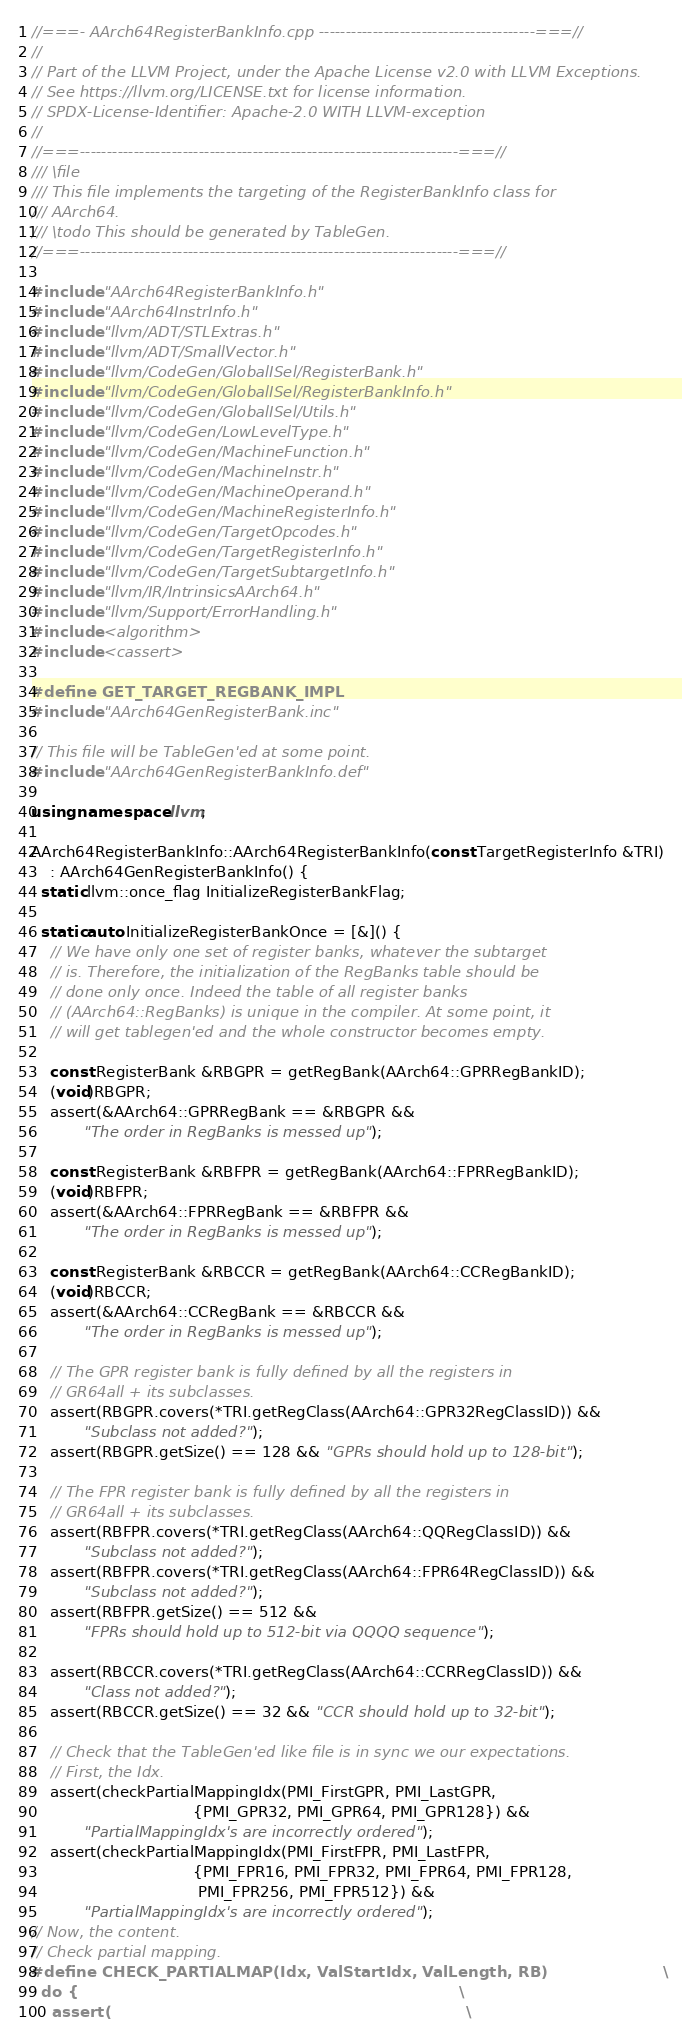<code> <loc_0><loc_0><loc_500><loc_500><_C++_>//===- AArch64RegisterBankInfo.cpp ----------------------------------------===//
//
// Part of the LLVM Project, under the Apache License v2.0 with LLVM Exceptions.
// See https://llvm.org/LICENSE.txt for license information.
// SPDX-License-Identifier: Apache-2.0 WITH LLVM-exception
//
//===----------------------------------------------------------------------===//
/// \file
/// This file implements the targeting of the RegisterBankInfo class for
/// AArch64.
/// \todo This should be generated by TableGen.
//===----------------------------------------------------------------------===//

#include "AArch64RegisterBankInfo.h"
#include "AArch64InstrInfo.h"
#include "llvm/ADT/STLExtras.h"
#include "llvm/ADT/SmallVector.h"
#include "llvm/CodeGen/GlobalISel/RegisterBank.h"
#include "llvm/CodeGen/GlobalISel/RegisterBankInfo.h"
#include "llvm/CodeGen/GlobalISel/Utils.h"
#include "llvm/CodeGen/LowLevelType.h"
#include "llvm/CodeGen/MachineFunction.h"
#include "llvm/CodeGen/MachineInstr.h"
#include "llvm/CodeGen/MachineOperand.h"
#include "llvm/CodeGen/MachineRegisterInfo.h"
#include "llvm/CodeGen/TargetOpcodes.h"
#include "llvm/CodeGen/TargetRegisterInfo.h"
#include "llvm/CodeGen/TargetSubtargetInfo.h"
#include "llvm/IR/IntrinsicsAArch64.h"
#include "llvm/Support/ErrorHandling.h"
#include <algorithm>
#include <cassert>

#define GET_TARGET_REGBANK_IMPL
#include "AArch64GenRegisterBank.inc"

// This file will be TableGen'ed at some point.
#include "AArch64GenRegisterBankInfo.def"

using namespace llvm;

AArch64RegisterBankInfo::AArch64RegisterBankInfo(const TargetRegisterInfo &TRI)
    : AArch64GenRegisterBankInfo() {
  static llvm::once_flag InitializeRegisterBankFlag;

  static auto InitializeRegisterBankOnce = [&]() {
    // We have only one set of register banks, whatever the subtarget
    // is. Therefore, the initialization of the RegBanks table should be
    // done only once. Indeed the table of all register banks
    // (AArch64::RegBanks) is unique in the compiler. At some point, it
    // will get tablegen'ed and the whole constructor becomes empty.

    const RegisterBank &RBGPR = getRegBank(AArch64::GPRRegBankID);
    (void)RBGPR;
    assert(&AArch64::GPRRegBank == &RBGPR &&
           "The order in RegBanks is messed up");

    const RegisterBank &RBFPR = getRegBank(AArch64::FPRRegBankID);
    (void)RBFPR;
    assert(&AArch64::FPRRegBank == &RBFPR &&
           "The order in RegBanks is messed up");

    const RegisterBank &RBCCR = getRegBank(AArch64::CCRegBankID);
    (void)RBCCR;
    assert(&AArch64::CCRegBank == &RBCCR &&
           "The order in RegBanks is messed up");

    // The GPR register bank is fully defined by all the registers in
    // GR64all + its subclasses.
    assert(RBGPR.covers(*TRI.getRegClass(AArch64::GPR32RegClassID)) &&
           "Subclass not added?");
    assert(RBGPR.getSize() == 128 && "GPRs should hold up to 128-bit");

    // The FPR register bank is fully defined by all the registers in
    // GR64all + its subclasses.
    assert(RBFPR.covers(*TRI.getRegClass(AArch64::QQRegClassID)) &&
           "Subclass not added?");
    assert(RBFPR.covers(*TRI.getRegClass(AArch64::FPR64RegClassID)) &&
           "Subclass not added?");
    assert(RBFPR.getSize() == 512 &&
           "FPRs should hold up to 512-bit via QQQQ sequence");

    assert(RBCCR.covers(*TRI.getRegClass(AArch64::CCRRegClassID)) &&
           "Class not added?");
    assert(RBCCR.getSize() == 32 && "CCR should hold up to 32-bit");

    // Check that the TableGen'ed like file is in sync we our expectations.
    // First, the Idx.
    assert(checkPartialMappingIdx(PMI_FirstGPR, PMI_LastGPR,
                                  {PMI_GPR32, PMI_GPR64, PMI_GPR128}) &&
           "PartialMappingIdx's are incorrectly ordered");
    assert(checkPartialMappingIdx(PMI_FirstFPR, PMI_LastFPR,
                                  {PMI_FPR16, PMI_FPR32, PMI_FPR64, PMI_FPR128,
                                   PMI_FPR256, PMI_FPR512}) &&
           "PartialMappingIdx's are incorrectly ordered");
// Now, the content.
// Check partial mapping.
#define CHECK_PARTIALMAP(Idx, ValStartIdx, ValLength, RB)                      \
  do {                                                                         \
    assert(                                                                    \</code> 